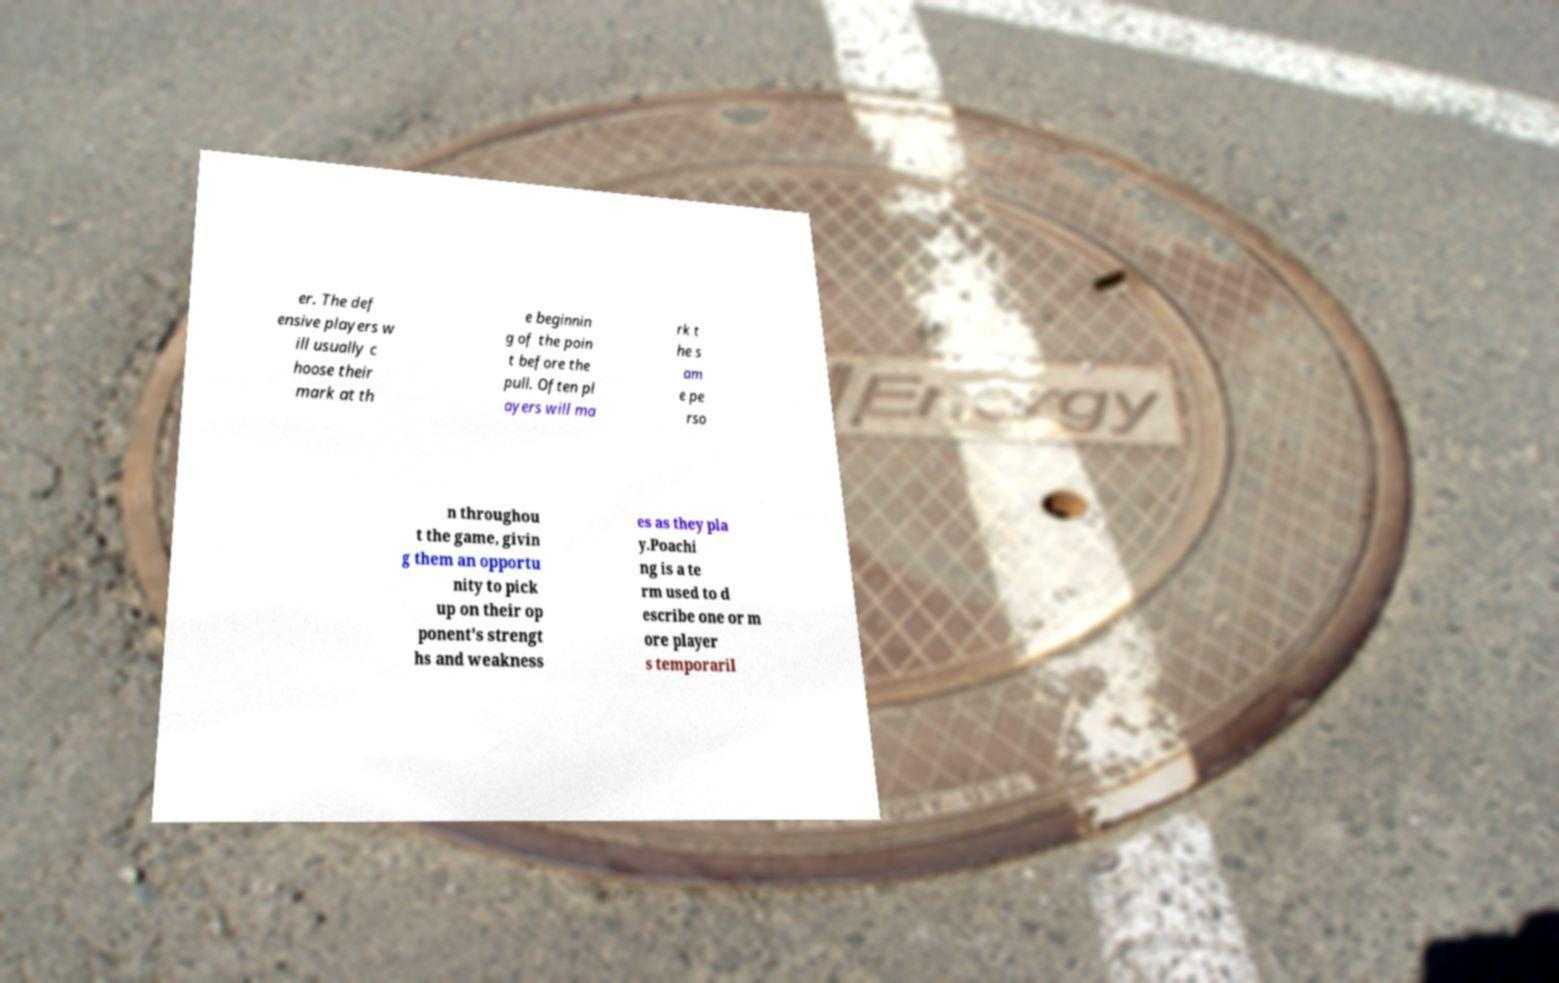Can you read and provide the text displayed in the image?This photo seems to have some interesting text. Can you extract and type it out for me? er. The def ensive players w ill usually c hoose their mark at th e beginnin g of the poin t before the pull. Often pl ayers will ma rk t he s am e pe rso n throughou t the game, givin g them an opportu nity to pick up on their op ponent's strengt hs and weakness es as they pla y.Poachi ng is a te rm used to d escribe one or m ore player s temporaril 